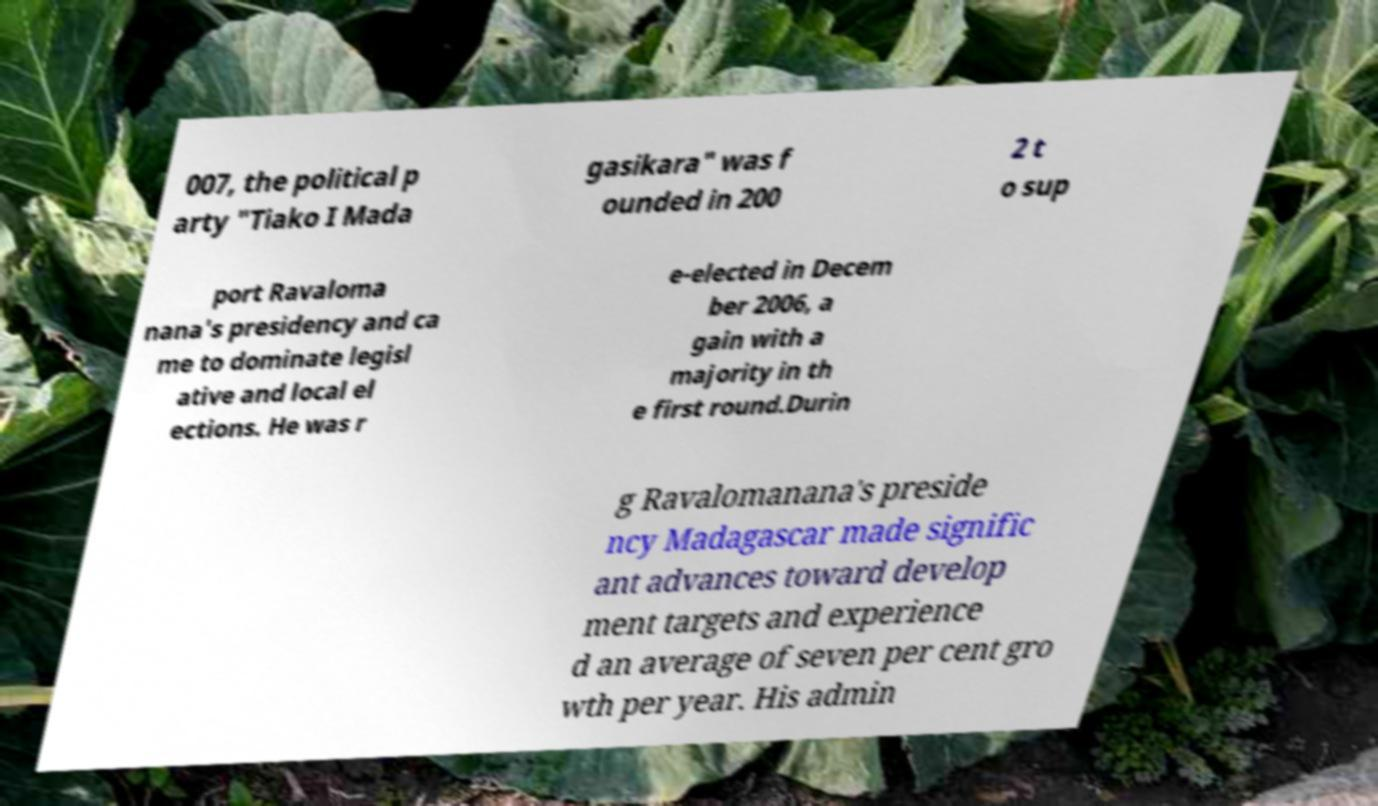Can you accurately transcribe the text from the provided image for me? 007, the political p arty "Tiako I Mada gasikara" was f ounded in 200 2 t o sup port Ravaloma nana's presidency and ca me to dominate legisl ative and local el ections. He was r e-elected in Decem ber 2006, a gain with a majority in th e first round.Durin g Ravalomanana's preside ncy Madagascar made signific ant advances toward develop ment targets and experience d an average of seven per cent gro wth per year. His admin 